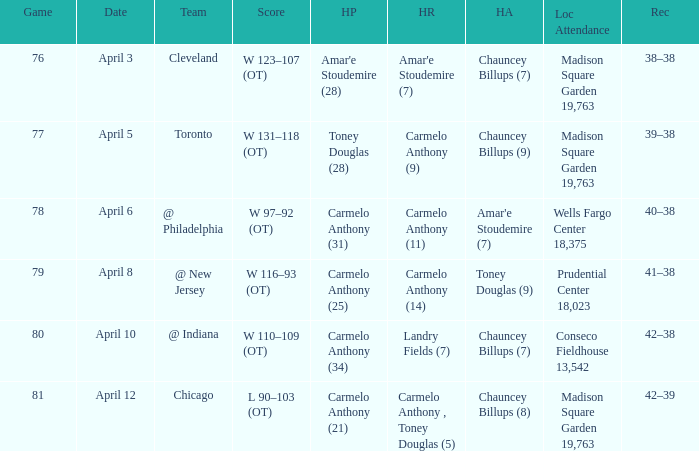Name the date for cleveland April 3. 